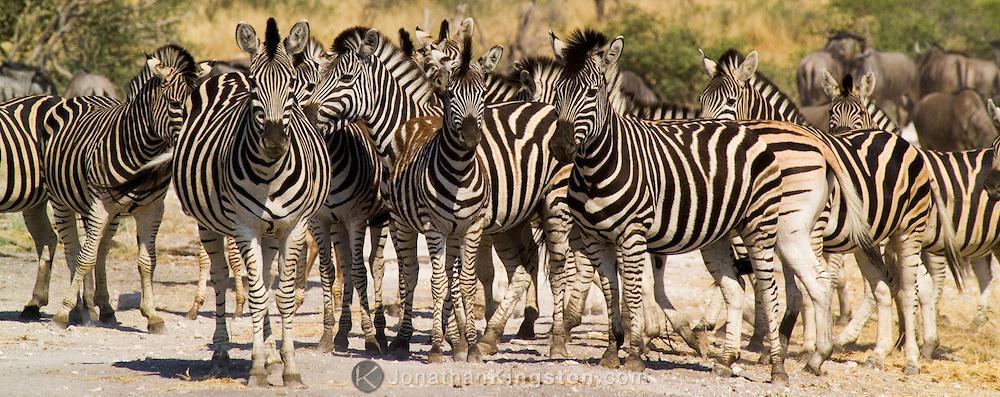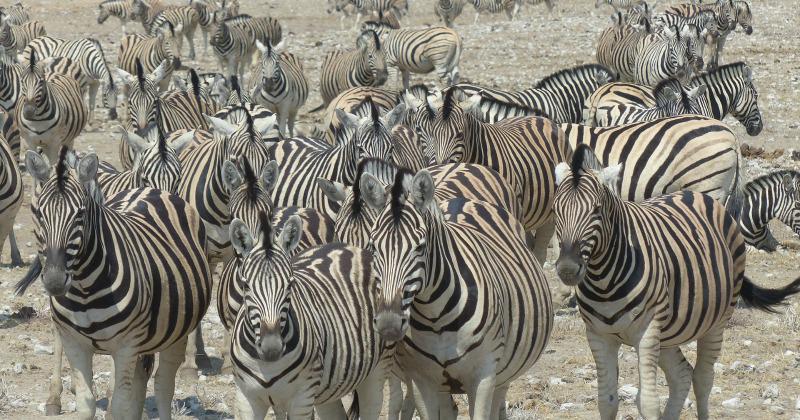The first image is the image on the left, the second image is the image on the right. Evaluate the accuracy of this statement regarding the images: "Some zebras are in water.". Is it true? Answer yes or no. No. The first image is the image on the left, the second image is the image on the right. Given the left and right images, does the statement "The left image shows several forward-turned zebra in the foreground, and the right image includes several zebras standing in water." hold true? Answer yes or no. No. 